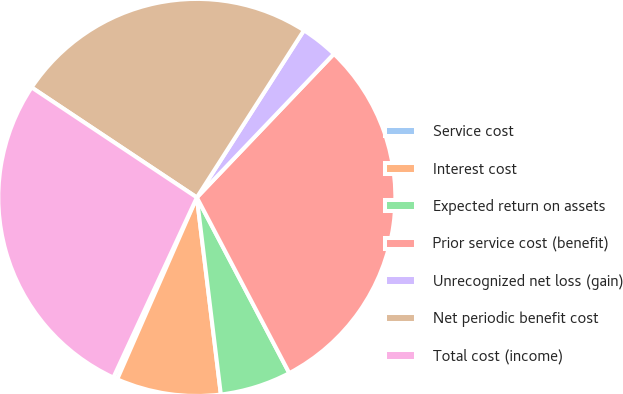Convert chart to OTSL. <chart><loc_0><loc_0><loc_500><loc_500><pie_chart><fcel>Service cost<fcel>Interest cost<fcel>Expected return on assets<fcel>Prior service cost (benefit)<fcel>Unrecognized net loss (gain)<fcel>Net periodic benefit cost<fcel>Total cost (income)<nl><fcel>0.34%<fcel>8.5%<fcel>5.78%<fcel>30.16%<fcel>3.06%<fcel>24.72%<fcel>27.44%<nl></chart> 